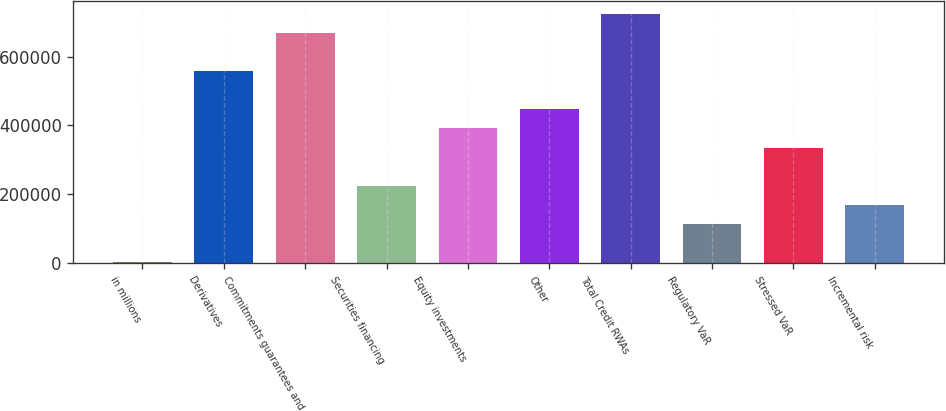Convert chart to OTSL. <chart><loc_0><loc_0><loc_500><loc_500><bar_chart><fcel>in millions<fcel>Derivatives<fcel>Commitments guarantees and<fcel>Securities financing<fcel>Equity investments<fcel>Other<fcel>Total Credit RWAs<fcel>Regulatory VaR<fcel>Stressed VaR<fcel>Incremental risk<nl><fcel>2018<fcel>558111<fcel>669330<fcel>224455<fcel>391283<fcel>446892<fcel>724939<fcel>113237<fcel>335674<fcel>168846<nl></chart> 